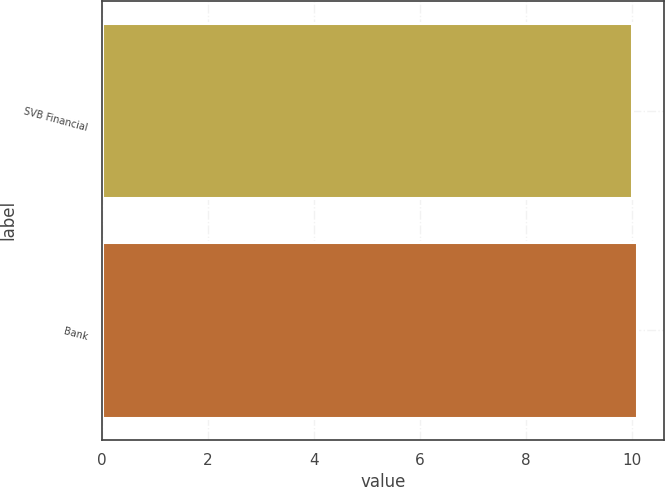Convert chart. <chart><loc_0><loc_0><loc_500><loc_500><bar_chart><fcel>SVB Financial<fcel>Bank<nl><fcel>10<fcel>10.1<nl></chart> 